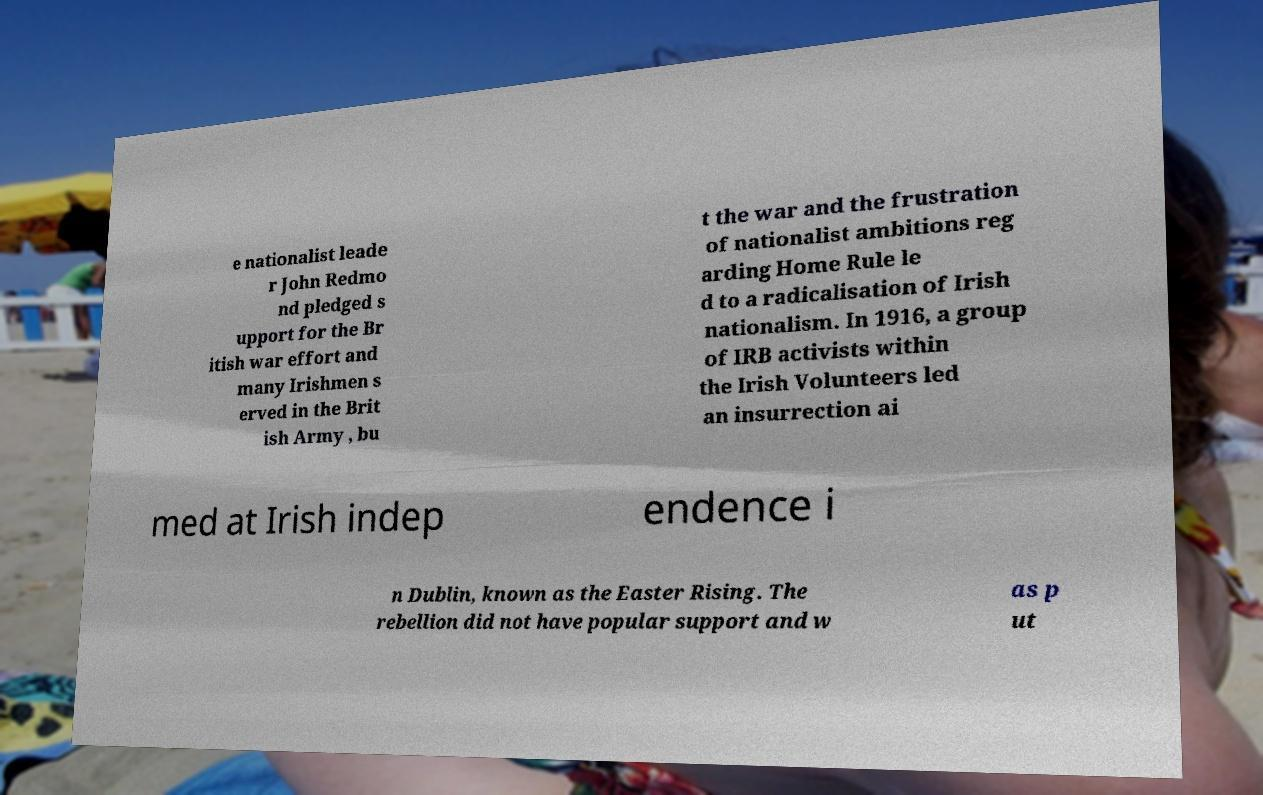For documentation purposes, I need the text within this image transcribed. Could you provide that? e nationalist leade r John Redmo nd pledged s upport for the Br itish war effort and many Irishmen s erved in the Brit ish Army , bu t the war and the frustration of nationalist ambitions reg arding Home Rule le d to a radicalisation of Irish nationalism. In 1916, a group of IRB activists within the Irish Volunteers led an insurrection ai med at Irish indep endence i n Dublin, known as the Easter Rising. The rebellion did not have popular support and w as p ut 